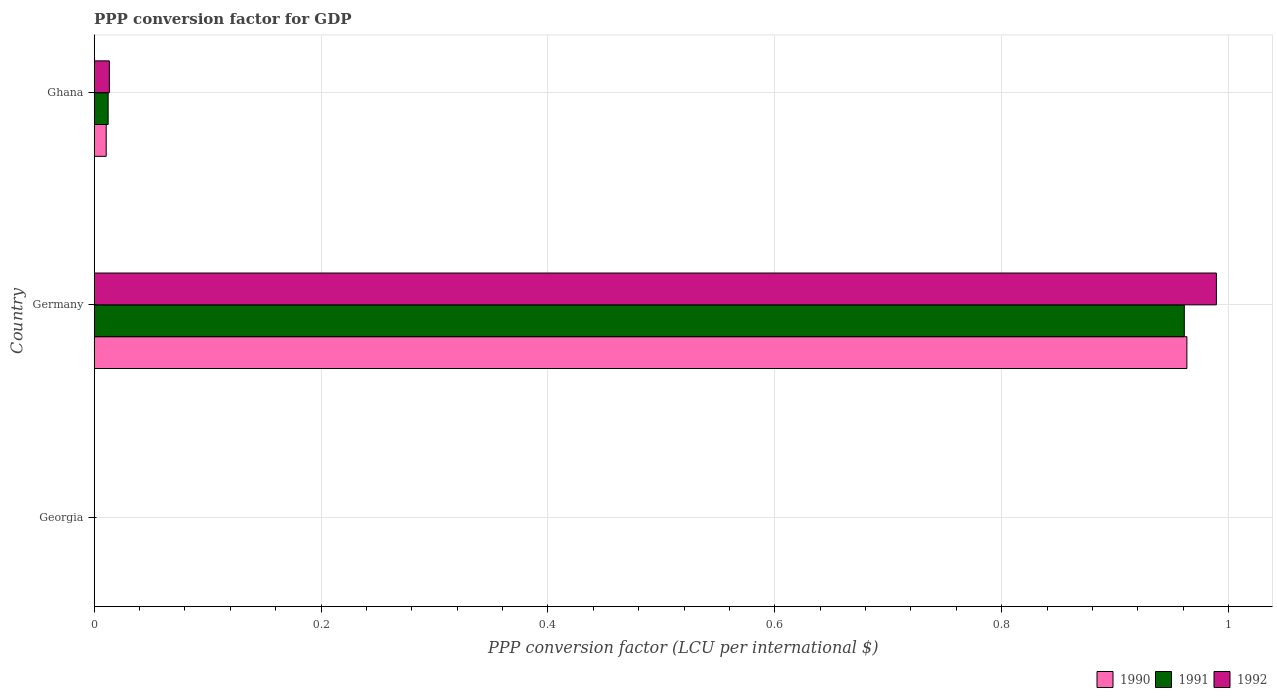How many groups of bars are there?
Make the answer very short. 3. How many bars are there on the 3rd tick from the top?
Offer a very short reply. 3. In how many cases, is the number of bars for a given country not equal to the number of legend labels?
Make the answer very short. 0. What is the PPP conversion factor for GDP in 1990 in Georgia?
Your answer should be very brief. 6.027407243891172e-7. Across all countries, what is the maximum PPP conversion factor for GDP in 1992?
Give a very brief answer. 0.99. Across all countries, what is the minimum PPP conversion factor for GDP in 1990?
Offer a terse response. 6.027407243891172e-7. In which country was the PPP conversion factor for GDP in 1990 minimum?
Your answer should be very brief. Georgia. What is the total PPP conversion factor for GDP in 1992 in the graph?
Keep it short and to the point. 1. What is the difference between the PPP conversion factor for GDP in 1990 in Germany and that in Ghana?
Give a very brief answer. 0.95. What is the difference between the PPP conversion factor for GDP in 1990 in Ghana and the PPP conversion factor for GDP in 1992 in Georgia?
Keep it short and to the point. 0.01. What is the average PPP conversion factor for GDP in 1990 per country?
Your answer should be very brief. 0.32. What is the difference between the PPP conversion factor for GDP in 1991 and PPP conversion factor for GDP in 1992 in Germany?
Your answer should be very brief. -0.03. What is the ratio of the PPP conversion factor for GDP in 1992 in Georgia to that in Ghana?
Provide a succinct answer. 0. Is the PPP conversion factor for GDP in 1991 in Germany less than that in Ghana?
Provide a short and direct response. No. What is the difference between the highest and the second highest PPP conversion factor for GDP in 1990?
Your answer should be very brief. 0.95. What is the difference between the highest and the lowest PPP conversion factor for GDP in 1990?
Your response must be concise. 0.96. What does the 1st bar from the top in Germany represents?
Your response must be concise. 1992. What does the 1st bar from the bottom in Georgia represents?
Your response must be concise. 1990. Is it the case that in every country, the sum of the PPP conversion factor for GDP in 1991 and PPP conversion factor for GDP in 1992 is greater than the PPP conversion factor for GDP in 1990?
Make the answer very short. Yes. How many countries are there in the graph?
Offer a terse response. 3. What is the difference between two consecutive major ticks on the X-axis?
Make the answer very short. 0.2. Does the graph contain grids?
Provide a short and direct response. Yes. How many legend labels are there?
Ensure brevity in your answer.  3. How are the legend labels stacked?
Offer a very short reply. Horizontal. What is the title of the graph?
Ensure brevity in your answer.  PPP conversion factor for GDP. What is the label or title of the X-axis?
Provide a succinct answer. PPP conversion factor (LCU per international $). What is the PPP conversion factor (LCU per international $) of 1990 in Georgia?
Your answer should be compact. 6.027407243891172e-7. What is the PPP conversion factor (LCU per international $) in 1991 in Georgia?
Provide a succinct answer. 9.46331563161503e-7. What is the PPP conversion factor (LCU per international $) of 1992 in Georgia?
Make the answer very short. 1.30487980325963e-5. What is the PPP conversion factor (LCU per international $) in 1990 in Germany?
Give a very brief answer. 0.96. What is the PPP conversion factor (LCU per international $) in 1991 in Germany?
Provide a succinct answer. 0.96. What is the PPP conversion factor (LCU per international $) in 1992 in Germany?
Offer a terse response. 0.99. What is the PPP conversion factor (LCU per international $) in 1990 in Ghana?
Provide a short and direct response. 0.01. What is the PPP conversion factor (LCU per international $) in 1991 in Ghana?
Your answer should be very brief. 0.01. What is the PPP conversion factor (LCU per international $) in 1992 in Ghana?
Offer a very short reply. 0.01. Across all countries, what is the maximum PPP conversion factor (LCU per international $) in 1990?
Ensure brevity in your answer.  0.96. Across all countries, what is the maximum PPP conversion factor (LCU per international $) of 1991?
Offer a terse response. 0.96. Across all countries, what is the maximum PPP conversion factor (LCU per international $) in 1992?
Keep it short and to the point. 0.99. Across all countries, what is the minimum PPP conversion factor (LCU per international $) in 1990?
Give a very brief answer. 6.027407243891172e-7. Across all countries, what is the minimum PPP conversion factor (LCU per international $) of 1991?
Give a very brief answer. 9.46331563161503e-7. Across all countries, what is the minimum PPP conversion factor (LCU per international $) in 1992?
Your answer should be very brief. 1.30487980325963e-5. What is the total PPP conversion factor (LCU per international $) in 1990 in the graph?
Your answer should be compact. 0.97. What is the total PPP conversion factor (LCU per international $) in 1991 in the graph?
Your answer should be very brief. 0.97. What is the total PPP conversion factor (LCU per international $) of 1992 in the graph?
Offer a terse response. 1. What is the difference between the PPP conversion factor (LCU per international $) in 1990 in Georgia and that in Germany?
Give a very brief answer. -0.96. What is the difference between the PPP conversion factor (LCU per international $) of 1991 in Georgia and that in Germany?
Your answer should be very brief. -0.96. What is the difference between the PPP conversion factor (LCU per international $) in 1992 in Georgia and that in Germany?
Make the answer very short. -0.99. What is the difference between the PPP conversion factor (LCU per international $) in 1990 in Georgia and that in Ghana?
Offer a very short reply. -0.01. What is the difference between the PPP conversion factor (LCU per international $) in 1991 in Georgia and that in Ghana?
Ensure brevity in your answer.  -0.01. What is the difference between the PPP conversion factor (LCU per international $) in 1992 in Georgia and that in Ghana?
Your answer should be compact. -0.01. What is the difference between the PPP conversion factor (LCU per international $) of 1990 in Germany and that in Ghana?
Provide a short and direct response. 0.95. What is the difference between the PPP conversion factor (LCU per international $) in 1991 in Germany and that in Ghana?
Your response must be concise. 0.95. What is the difference between the PPP conversion factor (LCU per international $) of 1990 in Georgia and the PPP conversion factor (LCU per international $) of 1991 in Germany?
Make the answer very short. -0.96. What is the difference between the PPP conversion factor (LCU per international $) in 1990 in Georgia and the PPP conversion factor (LCU per international $) in 1992 in Germany?
Provide a succinct answer. -0.99. What is the difference between the PPP conversion factor (LCU per international $) in 1991 in Georgia and the PPP conversion factor (LCU per international $) in 1992 in Germany?
Ensure brevity in your answer.  -0.99. What is the difference between the PPP conversion factor (LCU per international $) in 1990 in Georgia and the PPP conversion factor (LCU per international $) in 1991 in Ghana?
Your answer should be very brief. -0.01. What is the difference between the PPP conversion factor (LCU per international $) in 1990 in Georgia and the PPP conversion factor (LCU per international $) in 1992 in Ghana?
Offer a terse response. -0.01. What is the difference between the PPP conversion factor (LCU per international $) in 1991 in Georgia and the PPP conversion factor (LCU per international $) in 1992 in Ghana?
Your answer should be very brief. -0.01. What is the difference between the PPP conversion factor (LCU per international $) of 1990 in Germany and the PPP conversion factor (LCU per international $) of 1991 in Ghana?
Your response must be concise. 0.95. What is the difference between the PPP conversion factor (LCU per international $) in 1991 in Germany and the PPP conversion factor (LCU per international $) in 1992 in Ghana?
Make the answer very short. 0.95. What is the average PPP conversion factor (LCU per international $) in 1990 per country?
Your answer should be compact. 0.32. What is the average PPP conversion factor (LCU per international $) in 1991 per country?
Your answer should be compact. 0.32. What is the average PPP conversion factor (LCU per international $) of 1992 per country?
Offer a very short reply. 0.33. What is the difference between the PPP conversion factor (LCU per international $) of 1990 and PPP conversion factor (LCU per international $) of 1991 in Georgia?
Keep it short and to the point. -0. What is the difference between the PPP conversion factor (LCU per international $) of 1990 and PPP conversion factor (LCU per international $) of 1992 in Georgia?
Your response must be concise. -0. What is the difference between the PPP conversion factor (LCU per international $) of 1990 and PPP conversion factor (LCU per international $) of 1991 in Germany?
Your answer should be very brief. 0. What is the difference between the PPP conversion factor (LCU per international $) of 1990 and PPP conversion factor (LCU per international $) of 1992 in Germany?
Offer a very short reply. -0.03. What is the difference between the PPP conversion factor (LCU per international $) of 1991 and PPP conversion factor (LCU per international $) of 1992 in Germany?
Provide a short and direct response. -0.03. What is the difference between the PPP conversion factor (LCU per international $) in 1990 and PPP conversion factor (LCU per international $) in 1991 in Ghana?
Provide a short and direct response. -0. What is the difference between the PPP conversion factor (LCU per international $) of 1990 and PPP conversion factor (LCU per international $) of 1992 in Ghana?
Your answer should be very brief. -0. What is the difference between the PPP conversion factor (LCU per international $) of 1991 and PPP conversion factor (LCU per international $) of 1992 in Ghana?
Keep it short and to the point. -0. What is the ratio of the PPP conversion factor (LCU per international $) of 1991 in Georgia to that in Germany?
Ensure brevity in your answer.  0. What is the ratio of the PPP conversion factor (LCU per international $) of 1992 in Georgia to that in Germany?
Your response must be concise. 0. What is the ratio of the PPP conversion factor (LCU per international $) in 1990 in Georgia to that in Ghana?
Make the answer very short. 0. What is the ratio of the PPP conversion factor (LCU per international $) of 1991 in Georgia to that in Ghana?
Give a very brief answer. 0. What is the ratio of the PPP conversion factor (LCU per international $) of 1990 in Germany to that in Ghana?
Make the answer very short. 91.02. What is the ratio of the PPP conversion factor (LCU per international $) of 1991 in Germany to that in Ghana?
Keep it short and to the point. 78.16. What is the ratio of the PPP conversion factor (LCU per international $) in 1992 in Germany to that in Ghana?
Keep it short and to the point. 74.04. What is the difference between the highest and the second highest PPP conversion factor (LCU per international $) of 1990?
Provide a succinct answer. 0.95. What is the difference between the highest and the second highest PPP conversion factor (LCU per international $) of 1991?
Ensure brevity in your answer.  0.95. What is the difference between the highest and the lowest PPP conversion factor (LCU per international $) in 1990?
Your answer should be compact. 0.96. What is the difference between the highest and the lowest PPP conversion factor (LCU per international $) of 1992?
Make the answer very short. 0.99. 